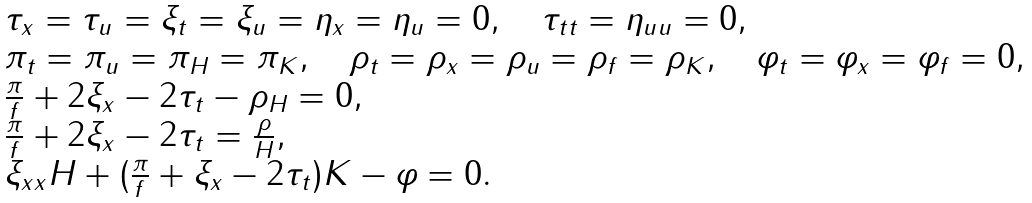Convert formula to latex. <formula><loc_0><loc_0><loc_500><loc_500>\begin{array} { l l } \tau _ { x } = \tau _ { u } = \xi _ { t } = \xi _ { u } = \eta _ { x } = \eta _ { u } = 0 , \quad \tau _ { t t } = \eta _ { u u } = 0 , \\ \pi _ { t } = \pi _ { u } = \pi _ { H } = \pi _ { K } , \quad \rho _ { t } = \rho _ { x } = \rho _ { u } = \rho _ { f } = \rho _ { K } , \quad \varphi _ { t } = \varphi _ { x } = \varphi _ { f } = 0 , \\ \frac { \pi } { f } + 2 \xi _ { x } - 2 \tau _ { t } - \rho _ { H } = 0 , \\ \frac { \pi } { f } + 2 \xi _ { x } - 2 \tau _ { t } = \frac { \rho } { H } , \\ \xi _ { x x } H + ( \frac { \pi } { f } + \xi _ { x } - 2 \tau _ { t } ) K - \varphi = 0 . \end{array}</formula> 